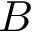Convert formula to latex. <formula><loc_0><loc_0><loc_500><loc_500>B</formula> 